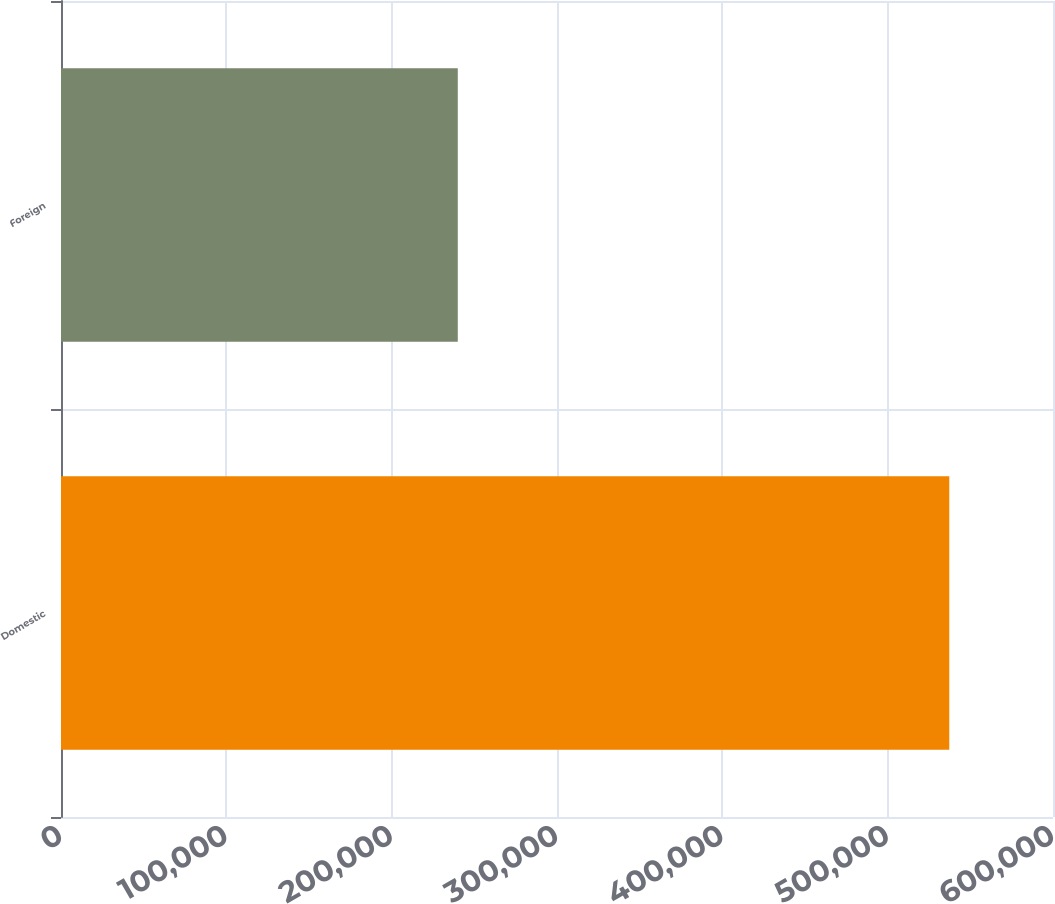Convert chart. <chart><loc_0><loc_0><loc_500><loc_500><bar_chart><fcel>Domestic<fcel>Foreign<nl><fcel>537271<fcel>239991<nl></chart> 